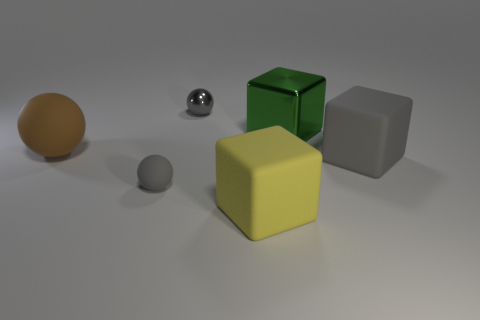What shape is the large gray thing that is made of the same material as the large yellow object?
Provide a succinct answer. Cube. Is the shape of the gray thing that is on the left side of the gray shiny ball the same as the small thing that is behind the brown ball?
Provide a short and direct response. Yes. Is the number of large yellow blocks on the right side of the large yellow rubber thing less than the number of large cubes that are to the right of the large green cube?
Provide a short and direct response. Yes. What is the shape of the tiny metallic object that is the same color as the small rubber object?
Keep it short and to the point. Sphere. How many brown things have the same size as the gray matte cube?
Offer a very short reply. 1. Does the big gray block to the right of the brown rubber thing have the same material as the large sphere?
Provide a short and direct response. Yes. Are any small yellow metallic balls visible?
Offer a terse response. No. There is a yellow cube that is the same material as the large brown thing; what size is it?
Provide a succinct answer. Large. Are there any big cylinders that have the same color as the shiny cube?
Provide a succinct answer. No. Does the matte sphere that is in front of the big brown thing have the same color as the large matte thing that is left of the small metallic object?
Offer a very short reply. No. 